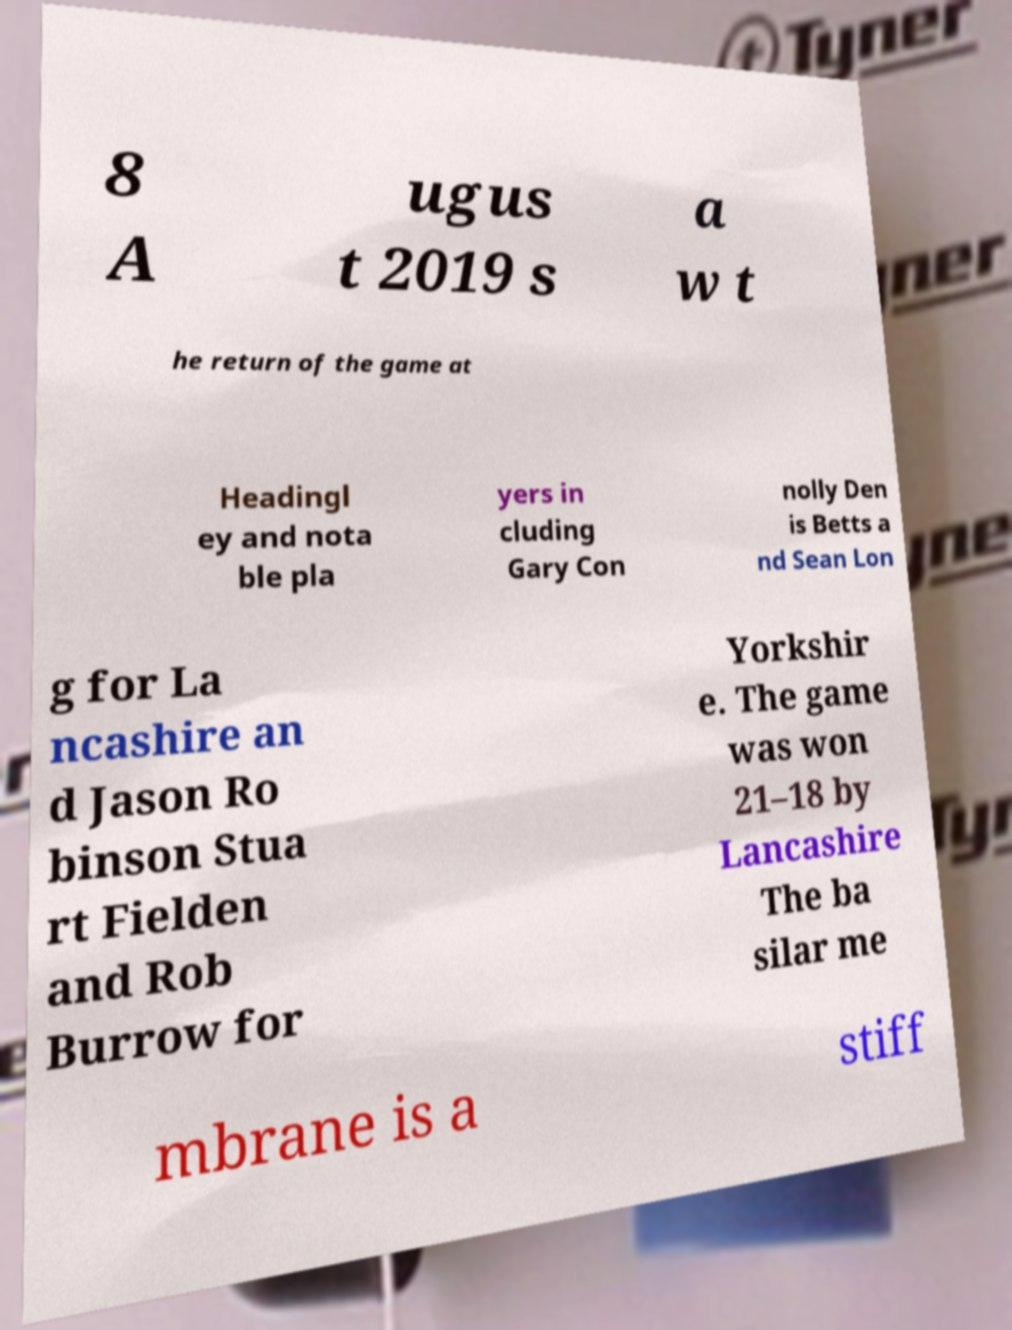Please read and relay the text visible in this image. What does it say? 8 A ugus t 2019 s a w t he return of the game at Headingl ey and nota ble pla yers in cluding Gary Con nolly Den is Betts a nd Sean Lon g for La ncashire an d Jason Ro binson Stua rt Fielden and Rob Burrow for Yorkshir e. The game was won 21–18 by Lancashire The ba silar me mbrane is a stiff 